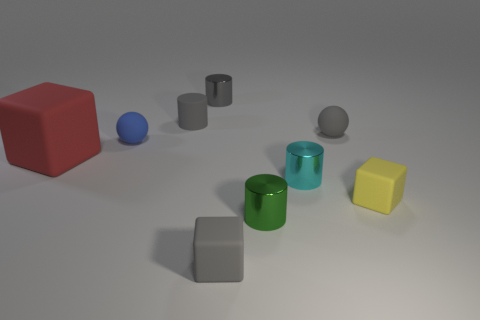Subtract all tiny gray cubes. How many cubes are left? 2 Subtract all brown balls. How many gray cylinders are left? 2 Subtract all cylinders. How many objects are left? 5 Subtract 2 cylinders. How many cylinders are left? 2 Subtract all yellow blocks. How many blocks are left? 2 Subtract 0 green balls. How many objects are left? 9 Subtract all red balls. Subtract all brown blocks. How many balls are left? 2 Subtract all small yellow objects. Subtract all tiny green things. How many objects are left? 7 Add 1 small gray cubes. How many small gray cubes are left? 2 Add 8 tiny spheres. How many tiny spheres exist? 10 